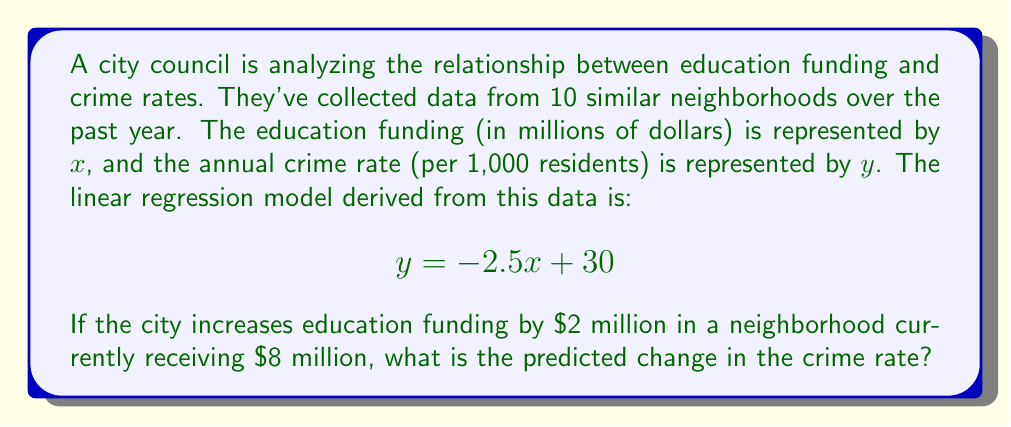Solve this math problem. To solve this problem, we'll follow these steps:

1) The given linear model is $y = -2.5x + 30$, where:
   $x$ = education funding in millions of dollars
   $y$ = crime rate per 1,000 residents

2) We need to calculate the difference in crime rates between two funding levels:
   Current funding: $x_1 = 8$ million
   Increased funding: $x_2 = 8 + 2 = 10$ million

3) Calculate the crime rate for current funding:
   $y_1 = -2.5(8) + 30 = -20 + 30 = 10$ crimes per 1,000 residents

4) Calculate the crime rate for increased funding:
   $y_2 = -2.5(10) + 30 = -25 + 30 = 5$ crimes per 1,000 residents

5) Calculate the change in crime rate:
   $\Delta y = y_2 - y_1 = 5 - 10 = -5$ crimes per 1,000 residents

The negative value indicates a decrease in the crime rate.
Answer: -5 crimes per 1,000 residents 